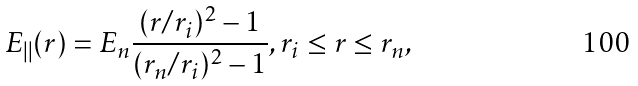<formula> <loc_0><loc_0><loc_500><loc_500>E _ { | | } ( r ) = E _ { n } \frac { ( r / r _ { i } ) ^ { 2 } - 1 } { ( r _ { n } / r _ { i } ) ^ { 2 } - 1 } , r _ { i } \leq r \leq r _ { n } ,</formula> 